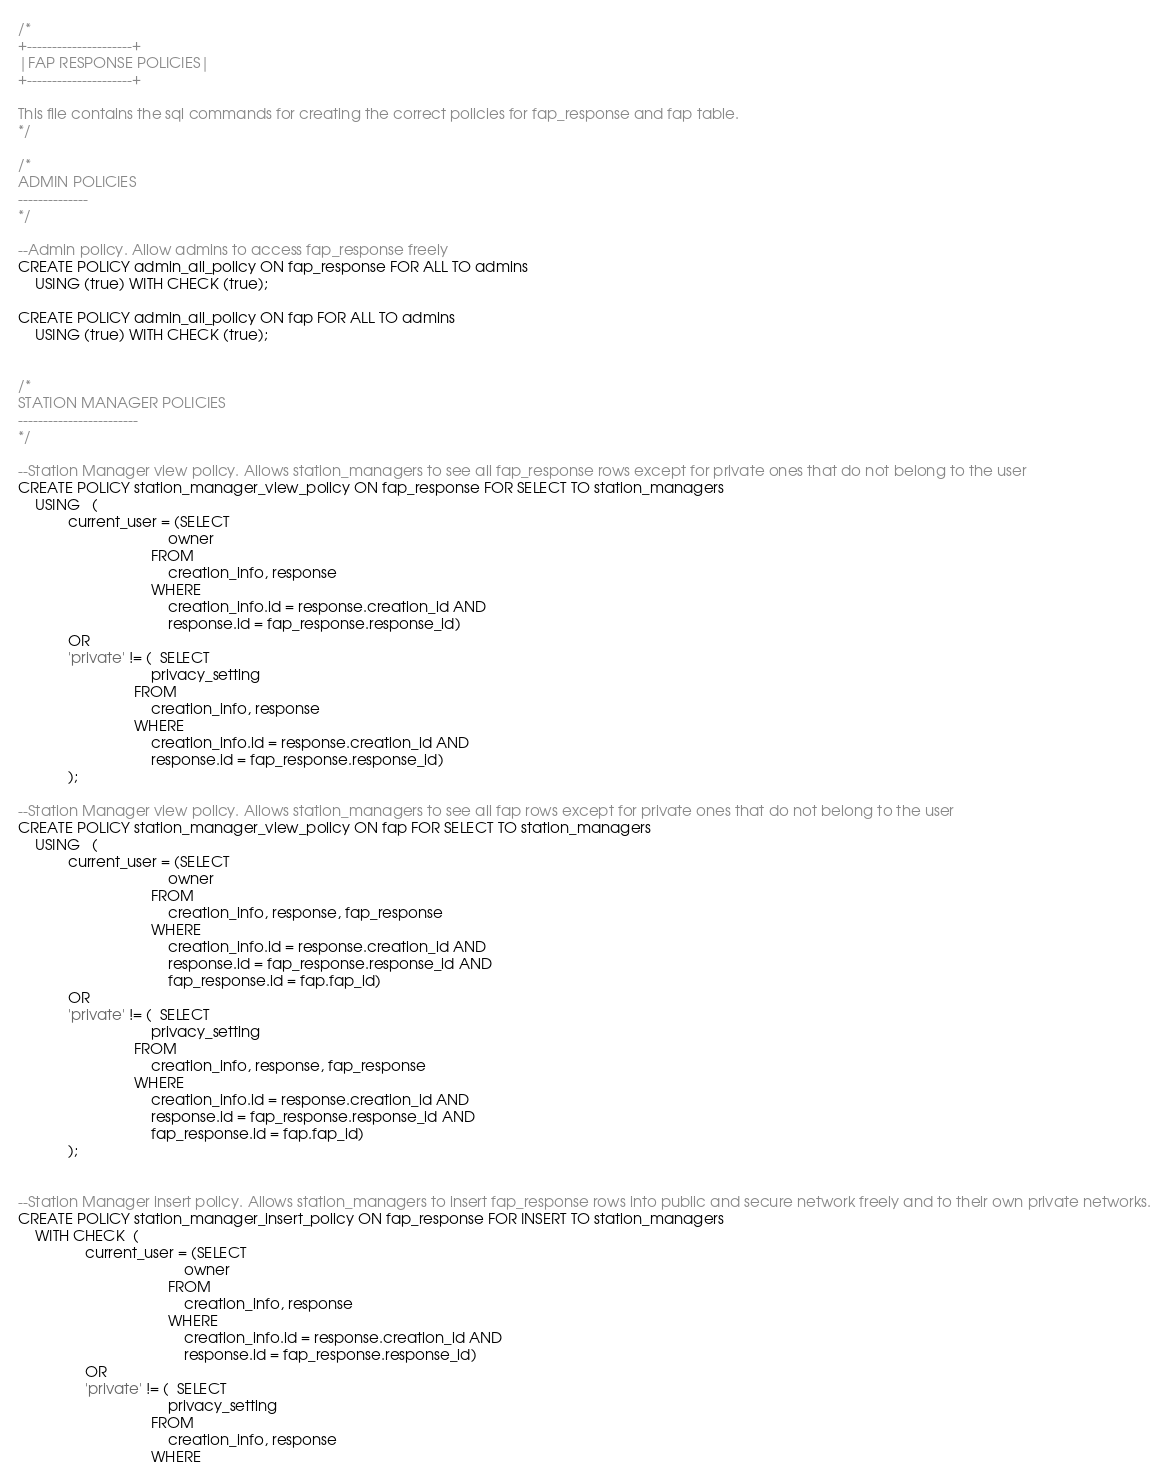<code> <loc_0><loc_0><loc_500><loc_500><_SQL_>/*
+---------------------+
|FAP RESPONSE POLICIES|
+---------------------+

This file contains the sql commands for creating the correct policies for fap_response and fap table.
*/

/*
ADMIN POLICIES
--------------
*/

--Admin policy. Allow admins to access fap_response freely 
CREATE POLICY admin_all_policy ON fap_response FOR ALL TO admins
    USING (true) WITH CHECK (true);

CREATE POLICY admin_all_policy ON fap FOR ALL TO admins
    USING (true) WITH CHECK (true);


/*
STATION MANAGER POLICIES
------------------------
*/

--Station Manager view policy. Allows station_managers to see all fap_response rows except for private ones that do not belong to the user
CREATE POLICY station_manager_view_policy ON fap_response FOR SELECT TO station_managers
    USING   (
            current_user = (SELECT 
                                    owner 
                                FROM 
                                    creation_info, response
                                WHERE 
                                    creation_info.id = response.creation_id AND 
                                    response.id = fap_response.response_id) 
            OR 
            'private' != (  SELECT 
                                privacy_setting 
                            FROM 
                                creation_info, response
                            WHERE 
                                creation_info.id = response.creation_id AND 
                                response.id = fap_response.response_id)
            );

--Station Manager view policy. Allows station_managers to see all fap rows except for private ones that do not belong to the user
CREATE POLICY station_manager_view_policy ON fap FOR SELECT TO station_managers
    USING   (
            current_user = (SELECT 
                                    owner 
                                FROM 
                                    creation_info, response, fap_response
                                WHERE 
                                    creation_info.id = response.creation_id AND 
                                    response.id = fap_response.response_id AND
                                    fap_response.id = fap.fap_id) 
            OR 
            'private' != (  SELECT 
                                privacy_setting 
                            FROM 
                                creation_info, response, fap_response
                            WHERE 
                                creation_info.id = response.creation_id AND 
                                response.id = fap_response.response_id AND
                                fap_response.id = fap.fap_id)
            );


--Station Manager insert policy. Allows station_managers to insert fap_response rows into public and secure network freely and to their own private networks.
CREATE POLICY station_manager_insert_policy ON fap_response FOR INSERT TO station_managers
    WITH CHECK  (
                current_user = (SELECT 
                                        owner 
                                    FROM 
                                        creation_info, response
                                    WHERE 
                                        creation_info.id = response.creation_id AND 
                                        response.id = fap_response.response_id)
                OR 
                'private' != (  SELECT 
                                    privacy_setting 
                                FROM 
                                    creation_info, response
                                WHERE </code> 